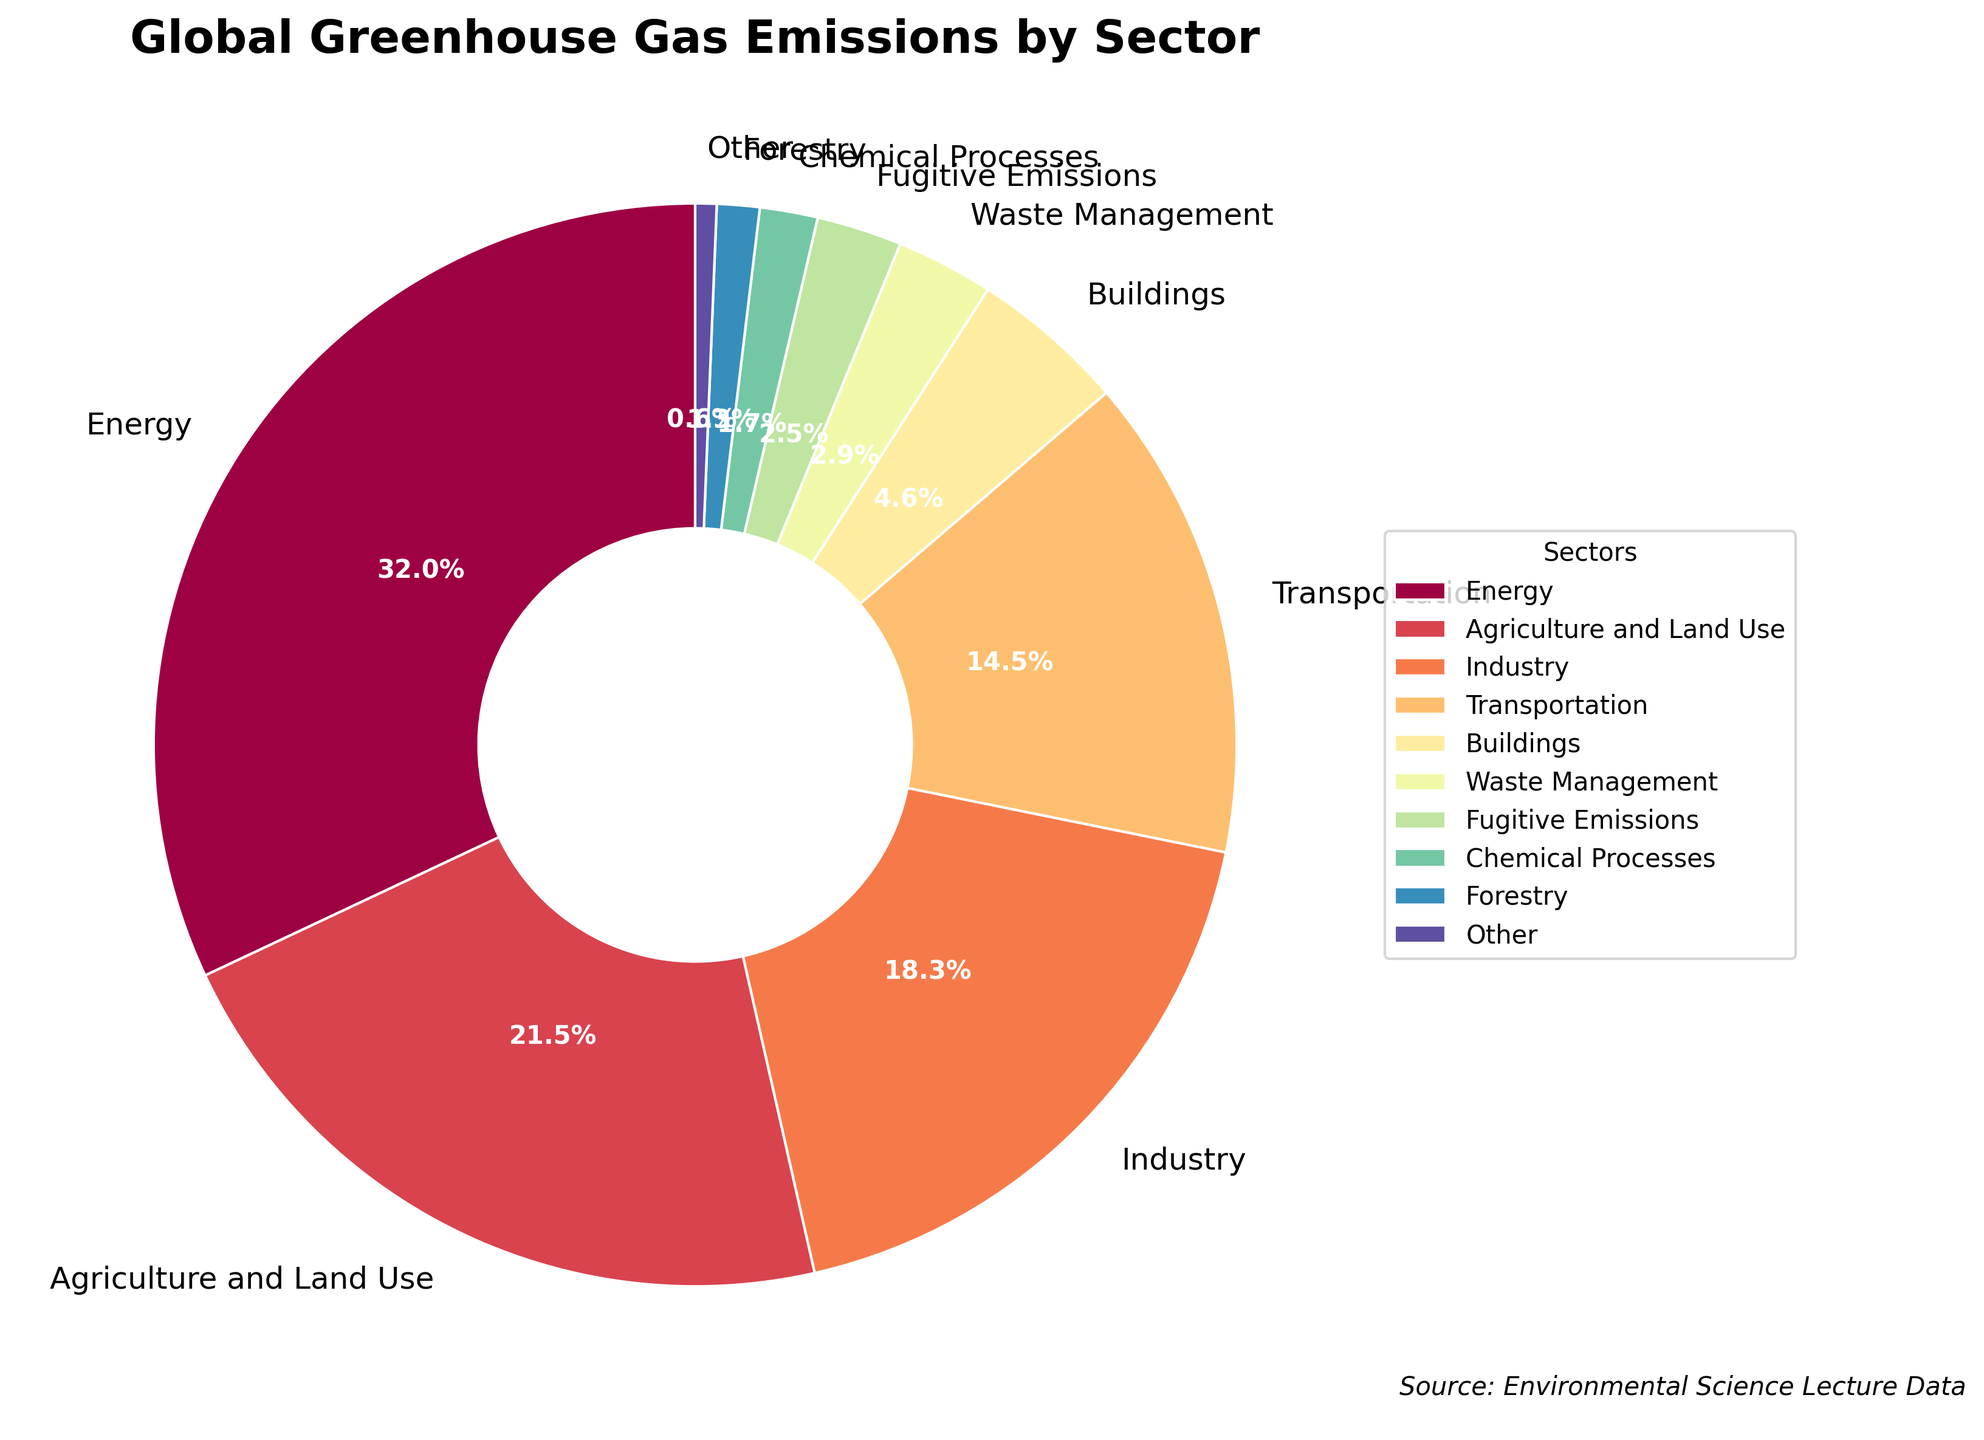What sector contributes the most to global greenhouse gas emissions? To determine the sector with the highest contribution, locate the sector with the largest percentage on the pie chart. The Energy sector has the highest percentage at 35.2%.
Answer: Energy What is the combined percentage of greenhouse gas emissions from Transportation and Buildings? To find the combined percentage, add the percentages of Transportation and Buildings. Transportation is 15.9% and Buildings is 5.1%, so 15.9% + 5.1% = 21%.
Answer: 21% How much more does the Industry sector contribute to greenhouse gas emissions compared to the Waste Management sector? Subtract the percentage of the Waste Management sector from the Industry sector. Industry is 20.1% and Waste Management is 3.2%, so 20.1% - 3.2% = 16.9%.
Answer: 16.9% Which sectors contribute less than 5% to global greenhouse gas emissions? Identify the sectors on the pie chart with percentages less than 5%. These sectors are Buildings (5.1%), Waste Management (3.2%), Fugitive Emissions (2.8%), Chemical Processes (1.9%), Forestry (1.4%), and Other (0.7%).
Answer: Waste Management, Fugitive Emissions, Chemical Processes, Forestry, Other What is the sum of greenhouse gas emissions for the sectors: Agriculture and Land Use, Buildings, and Chemical Processes? To find the total, add the percentages of Agriculture and Land Use, Buildings, and Chemical Processes. Agriculture and Land Use is 23.7%, Buildings is 5.1%, and Chemical Processes is 1.9%, so 23.7% + 5.1% + 1.9% = 30.7%.
Answer: 30.7% Which sector has the smallest wedge in the pie chart? Find the sector with the smallest percentage in the pie chart. The Other sector has the smallest percentage at 0.7%.
Answer: Other What is the difference in greenhouse gas emissions between the Agriculture and Land Use sector and the Transportation sector? Subtract the percentage of the Transportation sector from the Agriculture and Land Use sector. Agriculture and Land Use is 23.7% and Transportation is 15.9%, so 23.7% - 15.9% = 7.8%.
Answer: 7.8% Are there more sectors with contributions above 10% or below 10%? Count the number of sectors with contributions above and below 10%. Above 10%: Energy, Agriculture and Land Use, Industry, Transportation (4 sectors). Below 10%: Buildings, Waste Management, Fugitive Emissions, Chemical Processes, Forestry, Other (6 sectors).
Answer: Below 10% What is the combined contribution of the top three sectors in greenhouse gas emissions? Add the percentages of the top three sectors: Energy (35.2%), Agriculture and Land Use (23.7%), and Industry (20.1%). The combined contribution is 35.2% + 23.7% + 20.1% = 79%.
Answer: 79% Among the sectors contributing less than 5%, which one contributes the most to greenhouse gas emissions? Identify the sectors with percentages less than 5% and find the largest among them. Buildings have a contribution of 5.1%, but since it is more than 5%, consider the next one. Waste Management has the highest contribution at 3.2%.
Answer: Waste Management 